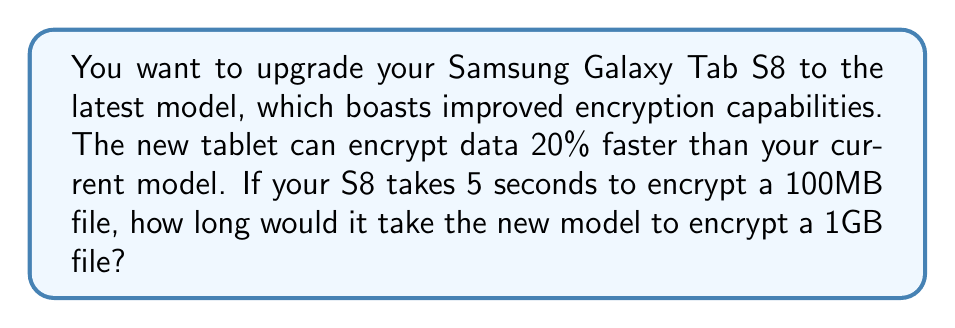Help me with this question. Let's approach this step-by-step:

1) First, let's calculate the encryption speed of the S8:
   $$\text{S8 Speed} = \frac{100 \text{ MB}}{5 \text{ seconds}} = 20 \text{ MB/s}$$

2) The new model is 20% faster, so its speed would be:
   $$\text{New Speed} = 20 \text{ MB/s} \times 1.20 = 24 \text{ MB/s}$$

3) Now, we need to convert 1GB to MB:
   $$1 \text{ GB} = 1000 \text{ MB}$$

4) To find the time needed to encrypt 1GB, we divide the file size by the encryption speed:
   $$\text{Time} = \frac{\text{File Size}}{\text{Encryption Speed}} = \frac{1000 \text{ MB}}{24 \text{ MB/s}}$$

5) Simplify:
   $$\text{Time} = \frac{1000}{24} \text{ seconds} = 41.6666... \text{ seconds}$$

6) Rounding to two decimal places:
   $$\text{Time} \approx 41.67 \text{ seconds}$$
Answer: 41.67 seconds 